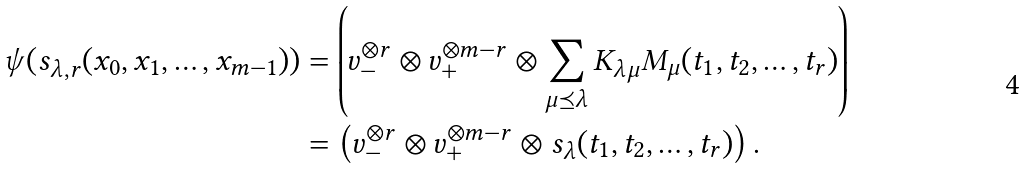Convert formula to latex. <formula><loc_0><loc_0><loc_500><loc_500>\psi ( s _ { \lambda , r } ( x _ { 0 } , x _ { 1 } , \dots , x _ { m - 1 } ) ) & = \left ( v _ { - } ^ { \otimes r } \otimes v _ { + } ^ { \otimes m - r } \otimes \sum _ { \mu \preceq \lambda } K _ { \lambda \mu } M _ { \mu } ( t _ { 1 } , t _ { 2 } , \dots , t _ { r } ) \right ) \\ & = \left ( v _ { - } ^ { \otimes r } \otimes v _ { + } ^ { \otimes m - r } \otimes s _ { \lambda } ( t _ { 1 } , t _ { 2 } , \dots , t _ { r } ) \right ) .</formula> 